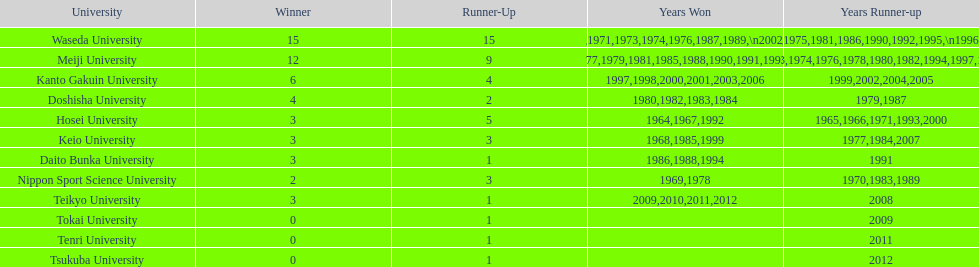How many championships does nippon sport science university have 2. 